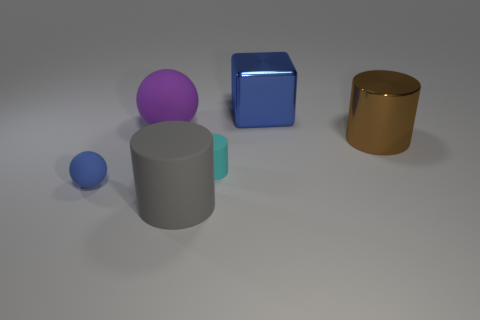How big is the object to the left of the large rubber thing left of the gray cylinder that is in front of the big purple rubber sphere?
Ensure brevity in your answer.  Small. How many blue cubes are to the right of the large brown object?
Your answer should be very brief. 0. The blue object behind the tiny matte object that is behind the tiny blue rubber sphere is made of what material?
Provide a succinct answer. Metal. Is there anything else that is the same size as the cyan object?
Provide a short and direct response. Yes. Do the block and the blue rubber thing have the same size?
Make the answer very short. No. How many objects are rubber objects in front of the cyan cylinder or matte balls that are in front of the small cylinder?
Your answer should be very brief. 2. Is the number of big purple balls on the left side of the blue rubber sphere greater than the number of large yellow cylinders?
Provide a short and direct response. No. What number of other things are the same shape as the large gray thing?
Provide a succinct answer. 2. There is a thing that is behind the brown cylinder and right of the big rubber sphere; what material is it?
Your response must be concise. Metal. How many objects are either tiny yellow cylinders or large metallic things?
Make the answer very short. 2. 